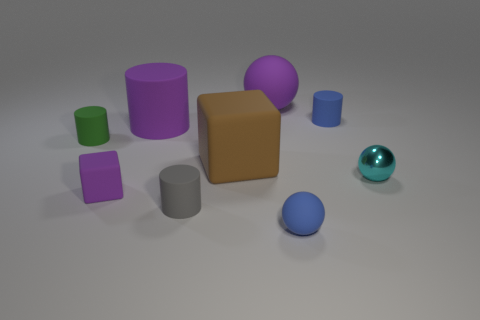Subtract all large purple matte spheres. How many spheres are left? 2 Subtract all cubes. How many objects are left? 7 Add 1 big matte cylinders. How many objects exist? 10 Subtract all gray cylinders. How many cylinders are left? 3 Subtract 1 blocks. How many blocks are left? 1 Add 2 small matte spheres. How many small matte spheres exist? 3 Subtract 0 red spheres. How many objects are left? 9 Subtract all gray blocks. Subtract all red cylinders. How many blocks are left? 2 Subtract all small matte cubes. Subtract all rubber blocks. How many objects are left? 6 Add 4 big brown matte cubes. How many big brown matte cubes are left? 5 